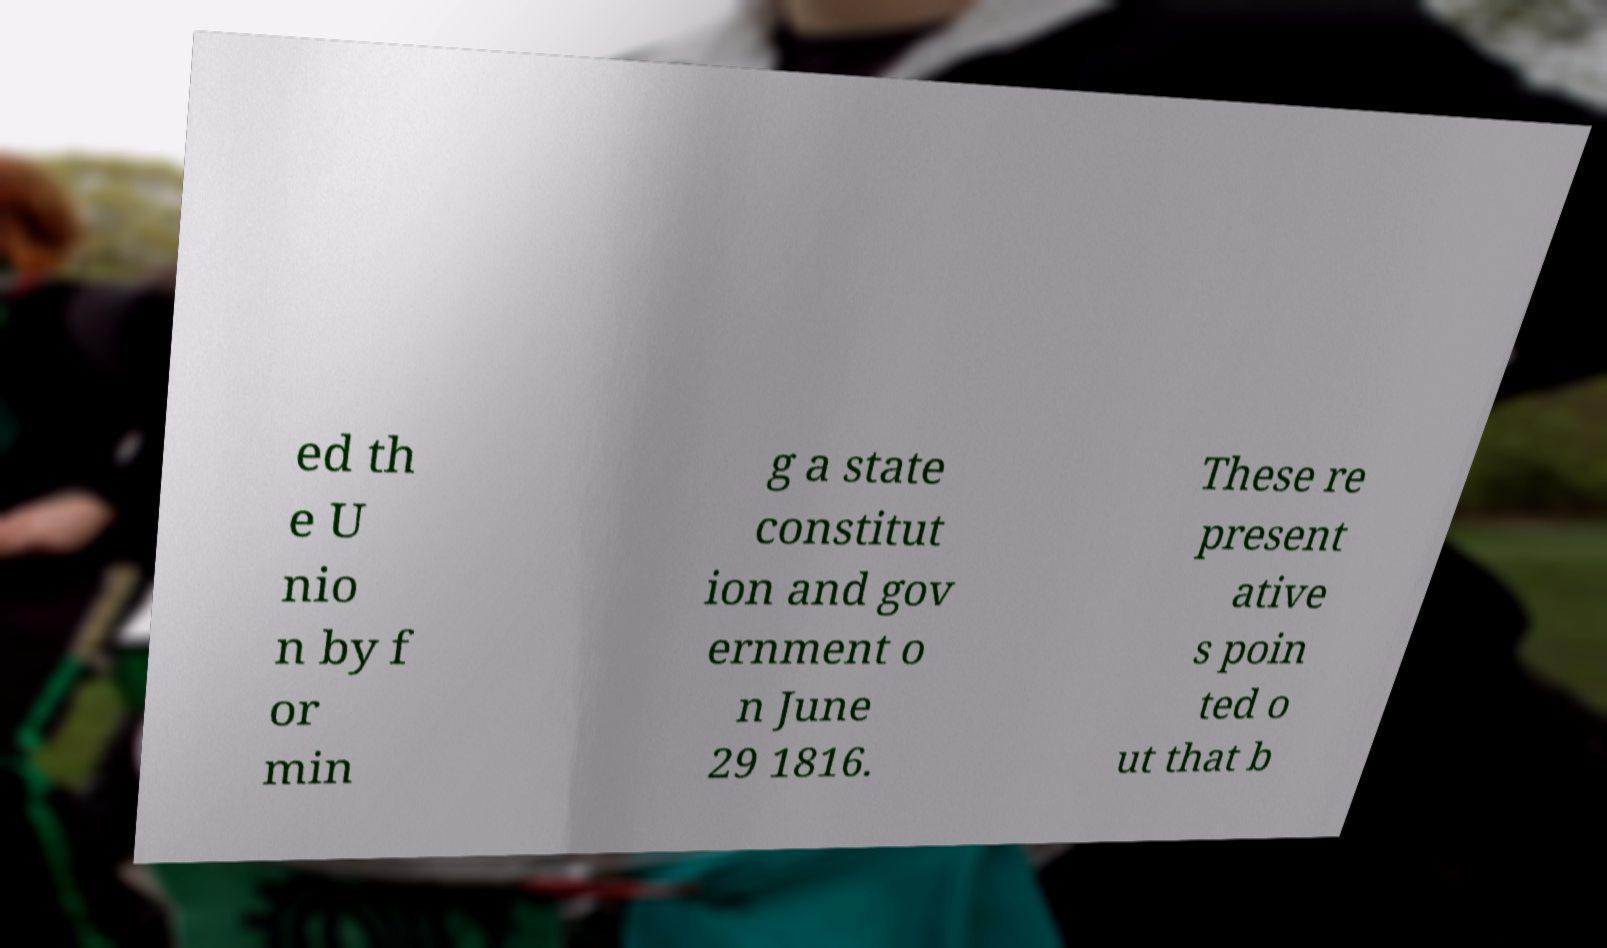For documentation purposes, I need the text within this image transcribed. Could you provide that? ed th e U nio n by f or min g a state constitut ion and gov ernment o n June 29 1816. These re present ative s poin ted o ut that b 